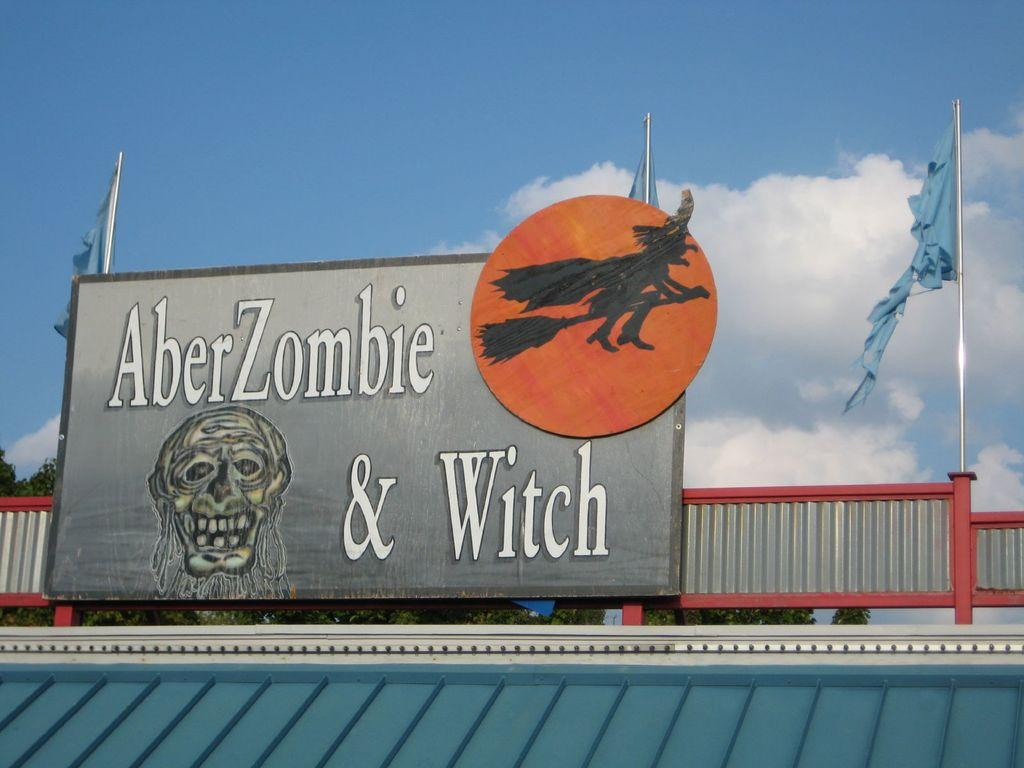Provide a one-sentence caption for the provided image. A sign states, "AberZombie and Witch" with flage on either corner. 